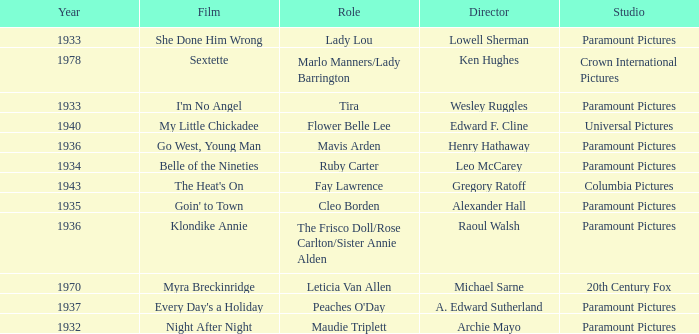What is the Year of the Film Klondike Annie? 1936.0. 